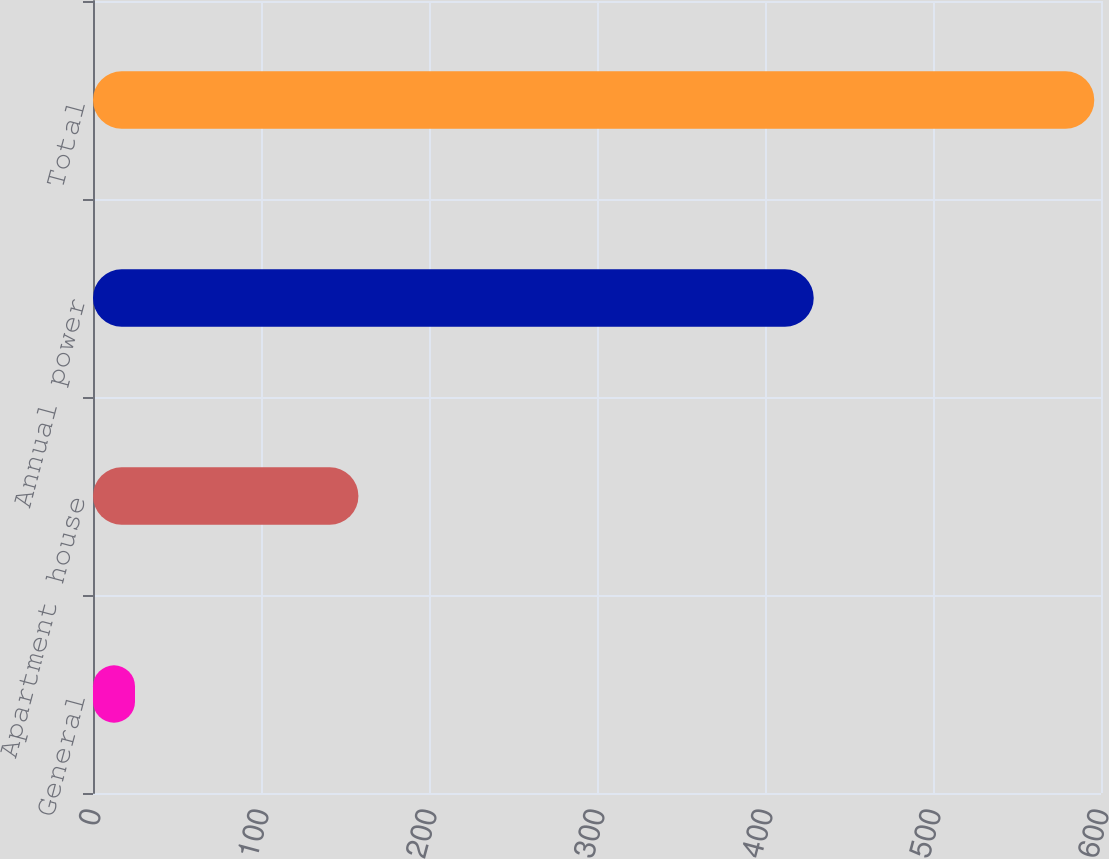<chart> <loc_0><loc_0><loc_500><loc_500><bar_chart><fcel>General<fcel>Apartment house<fcel>Annual power<fcel>Total<nl><fcel>25<fcel>158<fcel>429<fcel>596<nl></chart> 